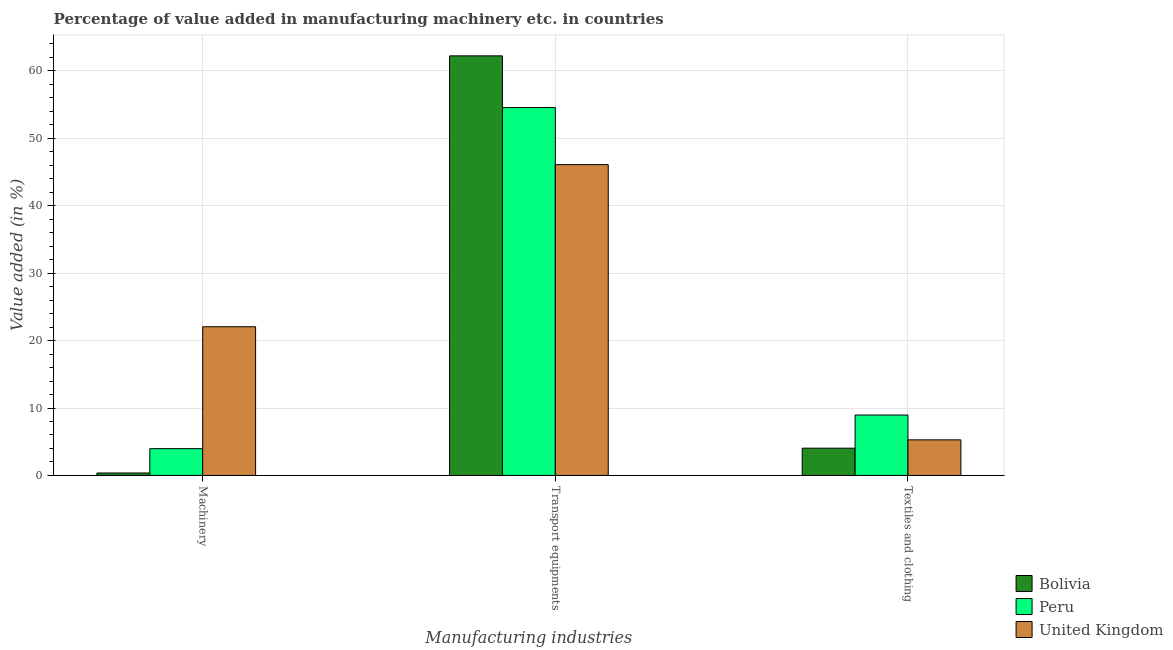How many different coloured bars are there?
Make the answer very short. 3. Are the number of bars on each tick of the X-axis equal?
Keep it short and to the point. Yes. How many bars are there on the 3rd tick from the left?
Your answer should be very brief. 3. What is the label of the 3rd group of bars from the left?
Offer a terse response. Textiles and clothing. What is the value added in manufacturing textile and clothing in Peru?
Provide a short and direct response. 8.96. Across all countries, what is the maximum value added in manufacturing machinery?
Your answer should be compact. 22.05. Across all countries, what is the minimum value added in manufacturing textile and clothing?
Your response must be concise. 4.04. In which country was the value added in manufacturing transport equipments minimum?
Keep it short and to the point. United Kingdom. What is the total value added in manufacturing transport equipments in the graph?
Provide a succinct answer. 162.87. What is the difference between the value added in manufacturing transport equipments in United Kingdom and that in Bolivia?
Offer a very short reply. -16.13. What is the difference between the value added in manufacturing textile and clothing in Bolivia and the value added in manufacturing transport equipments in United Kingdom?
Provide a succinct answer. -42.05. What is the average value added in manufacturing textile and clothing per country?
Keep it short and to the point. 6.09. What is the difference between the value added in manufacturing transport equipments and value added in manufacturing machinery in Bolivia?
Provide a short and direct response. 61.86. In how many countries, is the value added in manufacturing transport equipments greater than 62 %?
Keep it short and to the point. 1. What is the ratio of the value added in manufacturing textile and clothing in Peru to that in United Kingdom?
Offer a terse response. 1.7. What is the difference between the highest and the second highest value added in manufacturing textile and clothing?
Ensure brevity in your answer.  3.68. What is the difference between the highest and the lowest value added in manufacturing machinery?
Ensure brevity in your answer.  21.69. In how many countries, is the value added in manufacturing machinery greater than the average value added in manufacturing machinery taken over all countries?
Give a very brief answer. 1. What does the 3rd bar from the right in Textiles and clothing represents?
Offer a very short reply. Bolivia. Are all the bars in the graph horizontal?
Make the answer very short. No. How many countries are there in the graph?
Your answer should be very brief. 3. Does the graph contain any zero values?
Offer a very short reply. No. How are the legend labels stacked?
Give a very brief answer. Vertical. What is the title of the graph?
Your response must be concise. Percentage of value added in manufacturing machinery etc. in countries. What is the label or title of the X-axis?
Keep it short and to the point. Manufacturing industries. What is the label or title of the Y-axis?
Provide a succinct answer. Value added (in %). What is the Value added (in %) in Bolivia in Machinery?
Offer a terse response. 0.36. What is the Value added (in %) in Peru in Machinery?
Provide a succinct answer. 3.97. What is the Value added (in %) in United Kingdom in Machinery?
Your answer should be compact. 22.05. What is the Value added (in %) of Bolivia in Transport equipments?
Keep it short and to the point. 62.22. What is the Value added (in %) in Peru in Transport equipments?
Give a very brief answer. 54.55. What is the Value added (in %) of United Kingdom in Transport equipments?
Give a very brief answer. 46.09. What is the Value added (in %) in Bolivia in Textiles and clothing?
Keep it short and to the point. 4.04. What is the Value added (in %) in Peru in Textiles and clothing?
Give a very brief answer. 8.96. What is the Value added (in %) in United Kingdom in Textiles and clothing?
Offer a terse response. 5.28. Across all Manufacturing industries, what is the maximum Value added (in %) in Bolivia?
Offer a very short reply. 62.22. Across all Manufacturing industries, what is the maximum Value added (in %) in Peru?
Provide a short and direct response. 54.55. Across all Manufacturing industries, what is the maximum Value added (in %) in United Kingdom?
Make the answer very short. 46.09. Across all Manufacturing industries, what is the minimum Value added (in %) in Bolivia?
Offer a very short reply. 0.36. Across all Manufacturing industries, what is the minimum Value added (in %) of Peru?
Make the answer very short. 3.97. Across all Manufacturing industries, what is the minimum Value added (in %) of United Kingdom?
Give a very brief answer. 5.28. What is the total Value added (in %) of Bolivia in the graph?
Your answer should be compact. 66.63. What is the total Value added (in %) of Peru in the graph?
Your response must be concise. 67.48. What is the total Value added (in %) of United Kingdom in the graph?
Offer a very short reply. 73.42. What is the difference between the Value added (in %) in Bolivia in Machinery and that in Transport equipments?
Make the answer very short. -61.86. What is the difference between the Value added (in %) of Peru in Machinery and that in Transport equipments?
Keep it short and to the point. -50.58. What is the difference between the Value added (in %) of United Kingdom in Machinery and that in Transport equipments?
Your answer should be very brief. -24.04. What is the difference between the Value added (in %) in Bolivia in Machinery and that in Textiles and clothing?
Ensure brevity in your answer.  -3.68. What is the difference between the Value added (in %) in Peru in Machinery and that in Textiles and clothing?
Your response must be concise. -4.99. What is the difference between the Value added (in %) in United Kingdom in Machinery and that in Textiles and clothing?
Offer a very short reply. 16.77. What is the difference between the Value added (in %) in Bolivia in Transport equipments and that in Textiles and clothing?
Make the answer very short. 58.18. What is the difference between the Value added (in %) in Peru in Transport equipments and that in Textiles and clothing?
Offer a terse response. 45.6. What is the difference between the Value added (in %) in United Kingdom in Transport equipments and that in Textiles and clothing?
Give a very brief answer. 40.81. What is the difference between the Value added (in %) in Bolivia in Machinery and the Value added (in %) in Peru in Transport equipments?
Give a very brief answer. -54.19. What is the difference between the Value added (in %) of Bolivia in Machinery and the Value added (in %) of United Kingdom in Transport equipments?
Ensure brevity in your answer.  -45.73. What is the difference between the Value added (in %) in Peru in Machinery and the Value added (in %) in United Kingdom in Transport equipments?
Your answer should be compact. -42.12. What is the difference between the Value added (in %) of Bolivia in Machinery and the Value added (in %) of Peru in Textiles and clothing?
Provide a short and direct response. -8.59. What is the difference between the Value added (in %) of Bolivia in Machinery and the Value added (in %) of United Kingdom in Textiles and clothing?
Offer a terse response. -4.92. What is the difference between the Value added (in %) of Peru in Machinery and the Value added (in %) of United Kingdom in Textiles and clothing?
Keep it short and to the point. -1.31. What is the difference between the Value added (in %) in Bolivia in Transport equipments and the Value added (in %) in Peru in Textiles and clothing?
Your response must be concise. 53.27. What is the difference between the Value added (in %) of Bolivia in Transport equipments and the Value added (in %) of United Kingdom in Textiles and clothing?
Your answer should be compact. 56.94. What is the difference between the Value added (in %) of Peru in Transport equipments and the Value added (in %) of United Kingdom in Textiles and clothing?
Your response must be concise. 49.28. What is the average Value added (in %) in Bolivia per Manufacturing industries?
Provide a succinct answer. 22.21. What is the average Value added (in %) of Peru per Manufacturing industries?
Your answer should be very brief. 22.49. What is the average Value added (in %) in United Kingdom per Manufacturing industries?
Give a very brief answer. 24.47. What is the difference between the Value added (in %) in Bolivia and Value added (in %) in Peru in Machinery?
Offer a terse response. -3.61. What is the difference between the Value added (in %) of Bolivia and Value added (in %) of United Kingdom in Machinery?
Your response must be concise. -21.69. What is the difference between the Value added (in %) in Peru and Value added (in %) in United Kingdom in Machinery?
Your answer should be compact. -18.08. What is the difference between the Value added (in %) of Bolivia and Value added (in %) of Peru in Transport equipments?
Provide a short and direct response. 7.67. What is the difference between the Value added (in %) in Bolivia and Value added (in %) in United Kingdom in Transport equipments?
Your answer should be very brief. 16.13. What is the difference between the Value added (in %) of Peru and Value added (in %) of United Kingdom in Transport equipments?
Make the answer very short. 8.46. What is the difference between the Value added (in %) of Bolivia and Value added (in %) of Peru in Textiles and clothing?
Your response must be concise. -4.91. What is the difference between the Value added (in %) in Bolivia and Value added (in %) in United Kingdom in Textiles and clothing?
Your response must be concise. -1.24. What is the difference between the Value added (in %) in Peru and Value added (in %) in United Kingdom in Textiles and clothing?
Your response must be concise. 3.68. What is the ratio of the Value added (in %) in Bolivia in Machinery to that in Transport equipments?
Provide a short and direct response. 0.01. What is the ratio of the Value added (in %) in Peru in Machinery to that in Transport equipments?
Offer a terse response. 0.07. What is the ratio of the Value added (in %) of United Kingdom in Machinery to that in Transport equipments?
Make the answer very short. 0.48. What is the ratio of the Value added (in %) in Bolivia in Machinery to that in Textiles and clothing?
Your answer should be very brief. 0.09. What is the ratio of the Value added (in %) in Peru in Machinery to that in Textiles and clothing?
Provide a short and direct response. 0.44. What is the ratio of the Value added (in %) in United Kingdom in Machinery to that in Textiles and clothing?
Your answer should be very brief. 4.18. What is the ratio of the Value added (in %) in Bolivia in Transport equipments to that in Textiles and clothing?
Your answer should be compact. 15.39. What is the ratio of the Value added (in %) of Peru in Transport equipments to that in Textiles and clothing?
Give a very brief answer. 6.09. What is the ratio of the Value added (in %) in United Kingdom in Transport equipments to that in Textiles and clothing?
Ensure brevity in your answer.  8.73. What is the difference between the highest and the second highest Value added (in %) of Bolivia?
Provide a short and direct response. 58.18. What is the difference between the highest and the second highest Value added (in %) of Peru?
Give a very brief answer. 45.6. What is the difference between the highest and the second highest Value added (in %) in United Kingdom?
Keep it short and to the point. 24.04. What is the difference between the highest and the lowest Value added (in %) in Bolivia?
Offer a terse response. 61.86. What is the difference between the highest and the lowest Value added (in %) in Peru?
Offer a terse response. 50.58. What is the difference between the highest and the lowest Value added (in %) in United Kingdom?
Offer a very short reply. 40.81. 